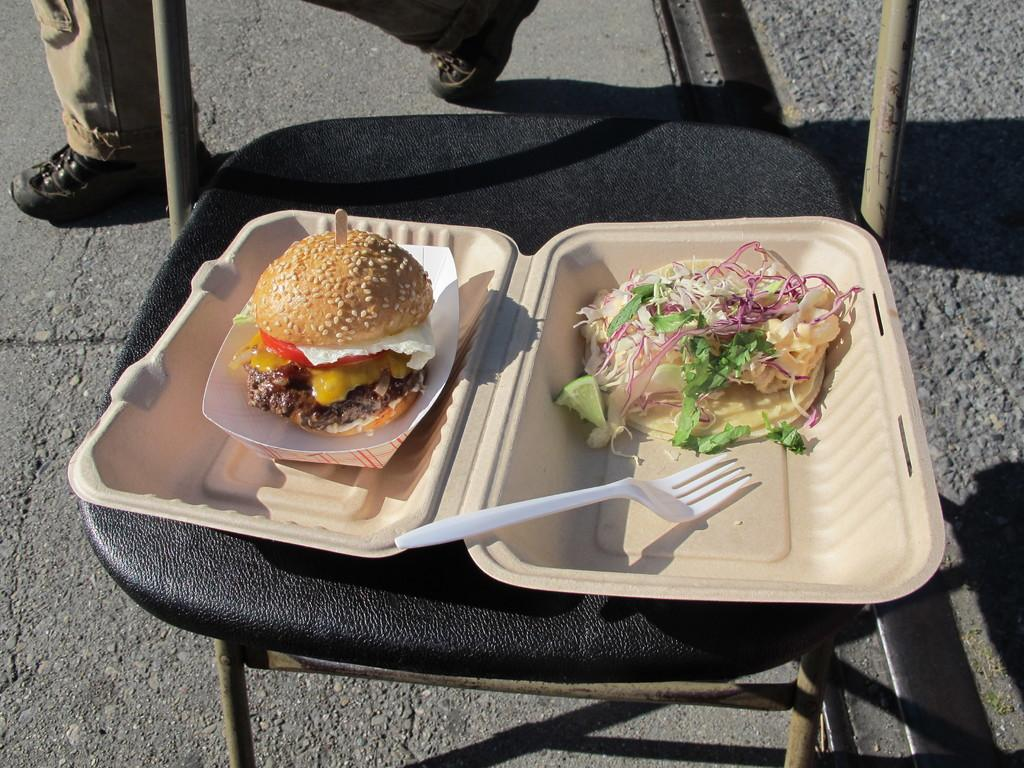What piece of furniture is present in the image? There is a chair in the image. What is placed on the chair? A box is placed on the chair. What type of food can be seen in the image? There is a salad and a burger in the image. What utensil is visible in the image? A fork is visible in the image. Whose leg can be seen in the image? There is a person's leg in the image. What type of footwear is present in the image? There are shoes in the image. What committee is meeting in the image? There is no committee meeting in the image; it only shows a chair, a box, a salad, a burger, a fork, a person's leg, and shoes. How does the person's breath appear in the image? There is no indication of the person's breath in the image. 